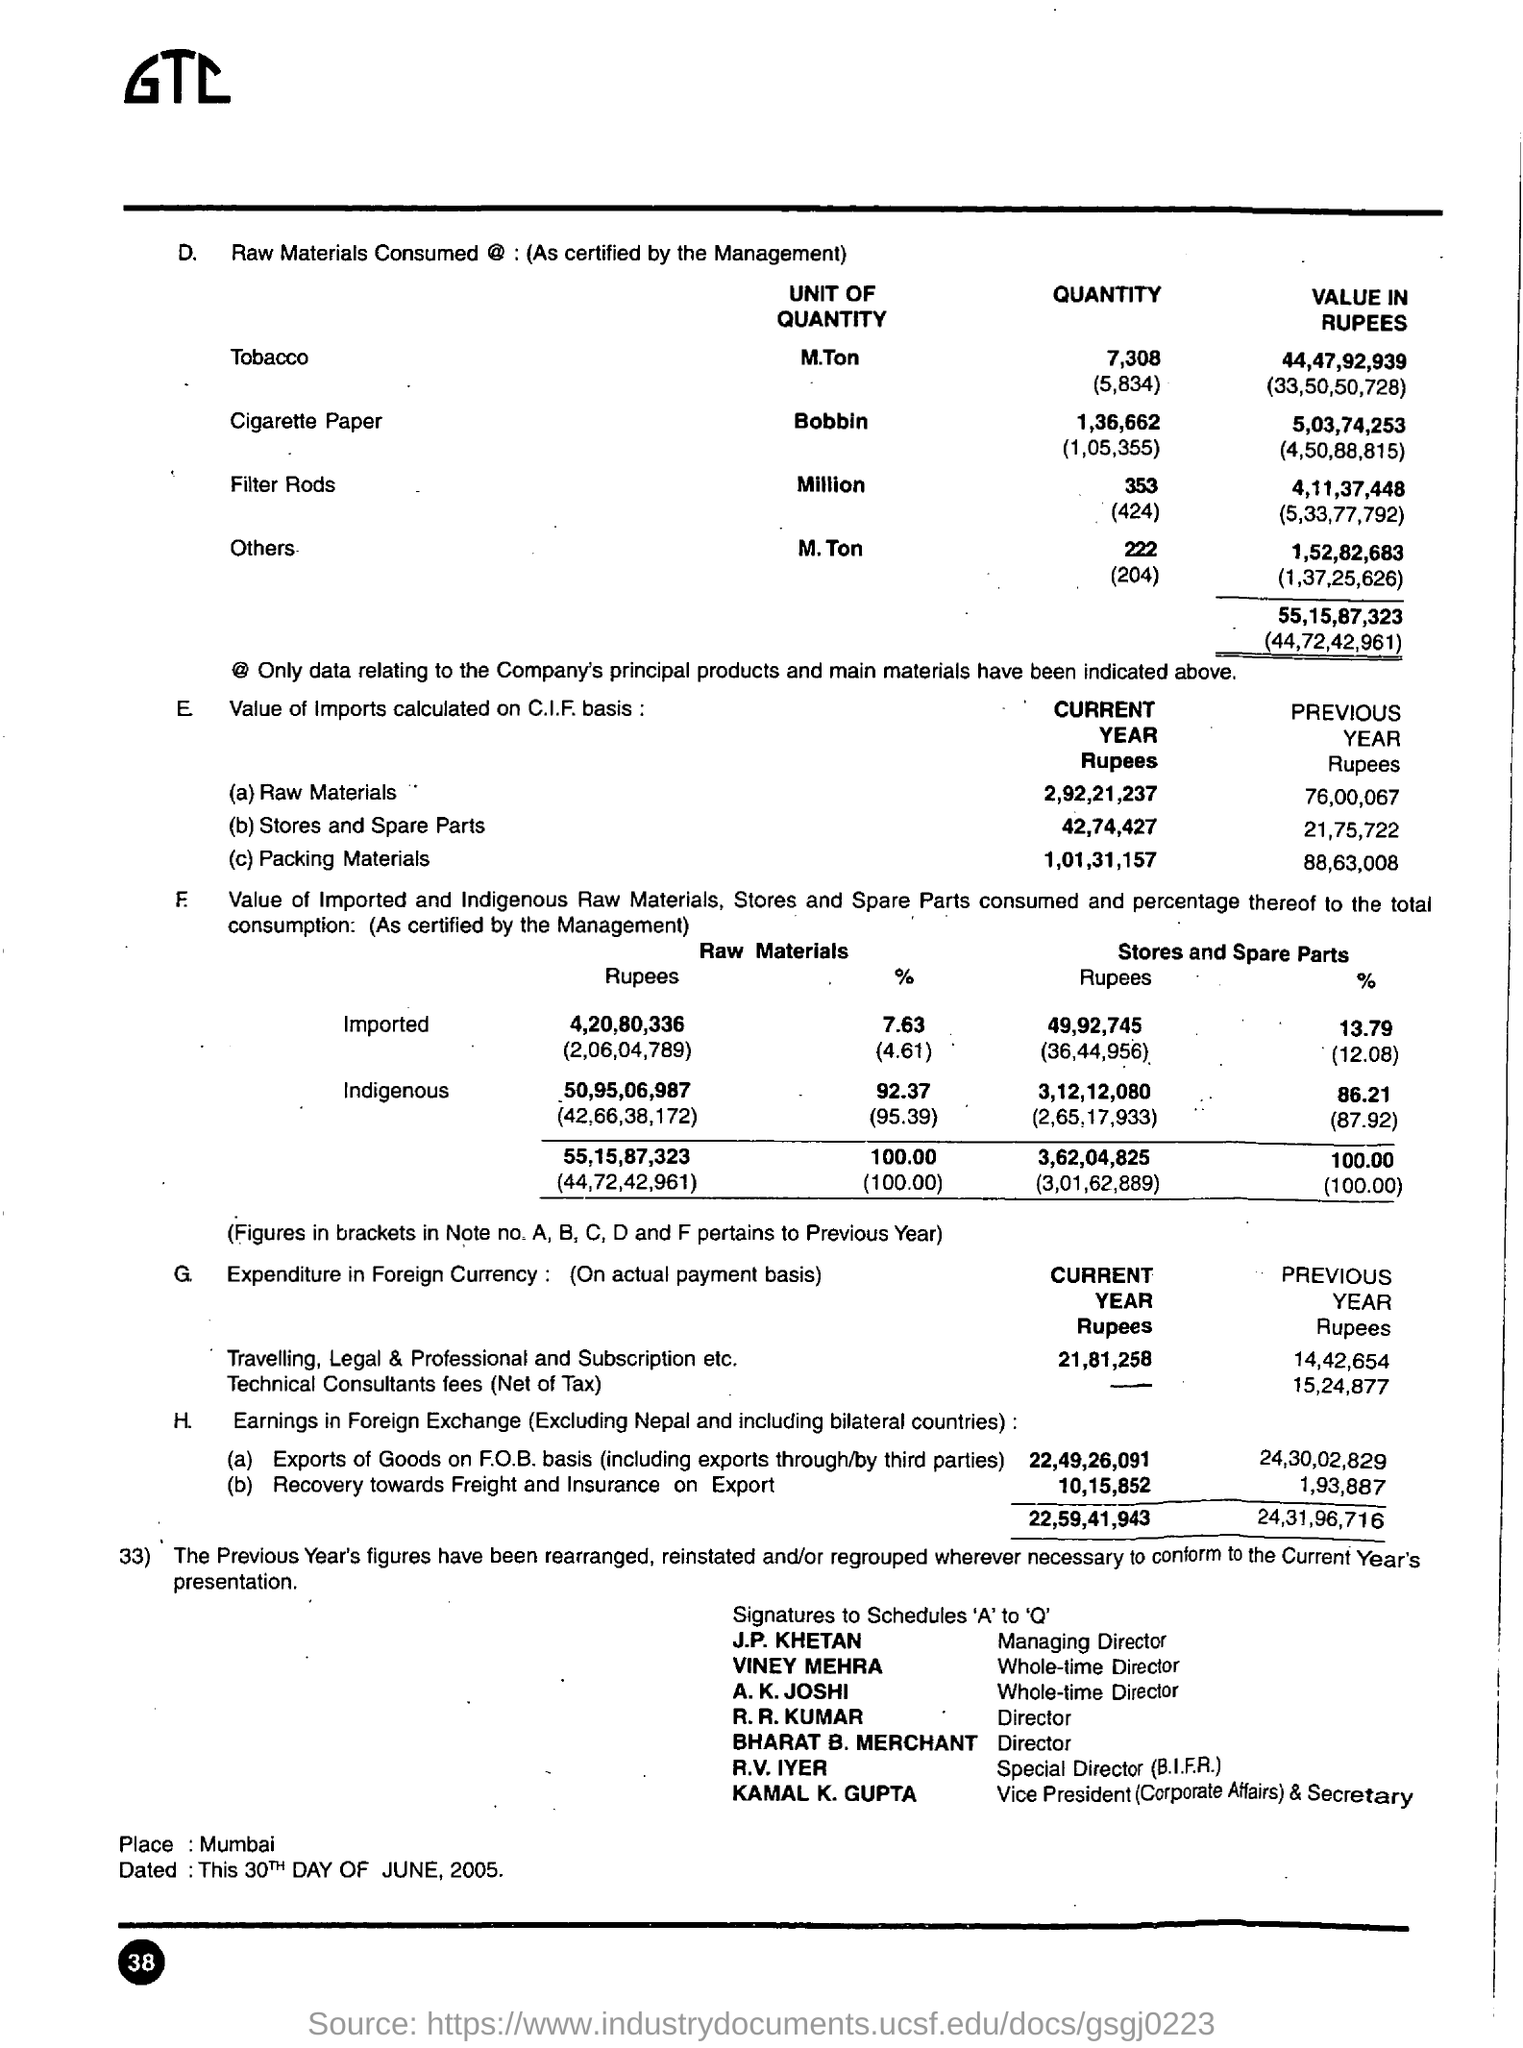Indicate a few pertinent items in this graphic. The place mentioned in the document is Mumbai. 